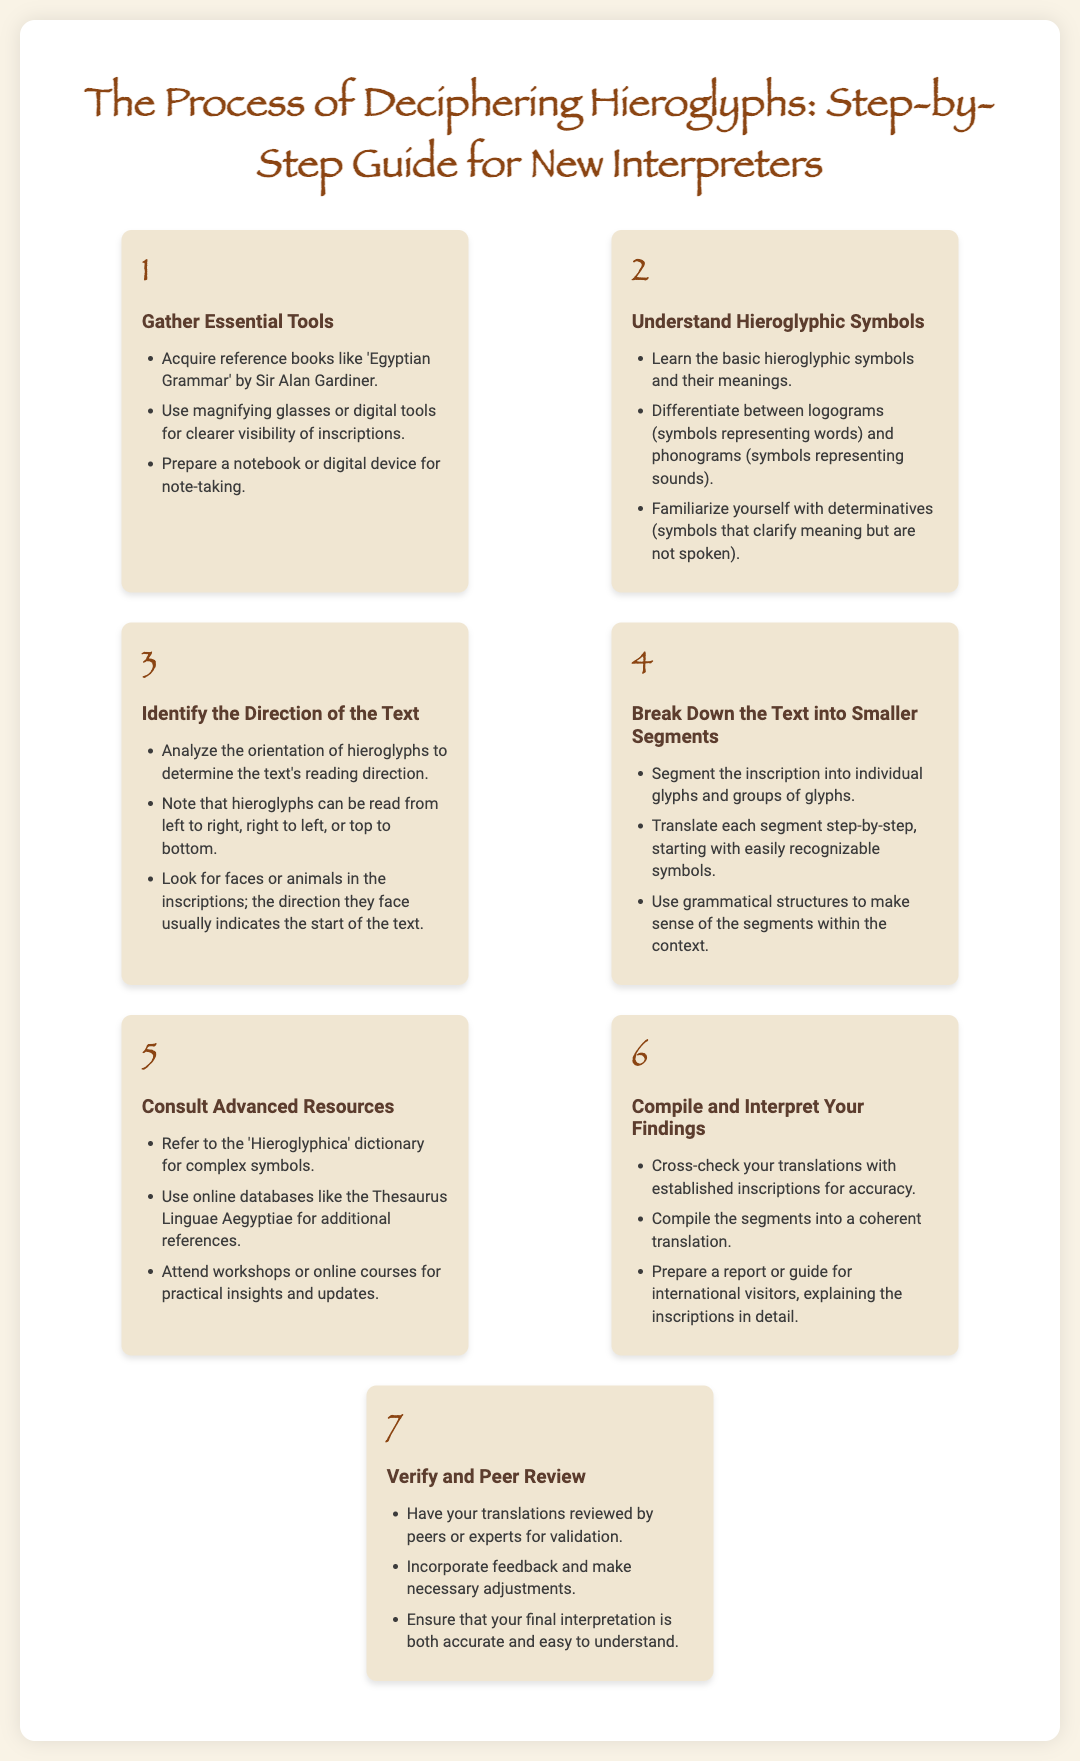What is the title of the guide? The guide's title is provided prominently at the top of the document.
Answer: The Process of Deciphering Hieroglyphs: Step-by-Step Guide for New Interpreters What is the first step in the process? The first step is listed at the beginning of the process steps section.
Answer: Gather Essential Tools How many main steps are outlined in the process? The document contains a clearly defined number of steps presented in order.
Answer: 7 What is suggested as a tool for clearer visibility of inscriptions? The document highlights certain tools that can enhance the clarity of inscriptions.
Answer: Magnifying glasses Which symbol type clarifies meaning but is not spoken? The document distinguishes between symbol types and indicates one category that serves a specific purpose.
Answer: Determinatives What should you do after compiling your findings? The document outlines a subsequent action following the compilation of your interpretations.
Answer: Verify and Peer Review What should you attend for practical insights and updates? The guide specifies formats for gaining deeper knowledge and current insights on hieroglyphs.
Answer: Workshops or online courses 